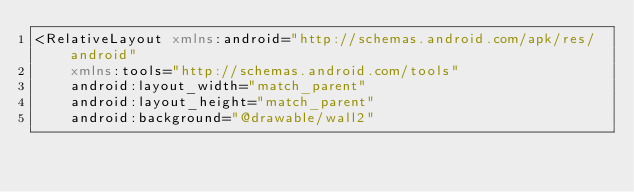<code> <loc_0><loc_0><loc_500><loc_500><_XML_><RelativeLayout xmlns:android="http://schemas.android.com/apk/res/android"
    xmlns:tools="http://schemas.android.com/tools"
    android:layout_width="match_parent"
    android:layout_height="match_parent"
    android:background="@drawable/wall2"</code> 